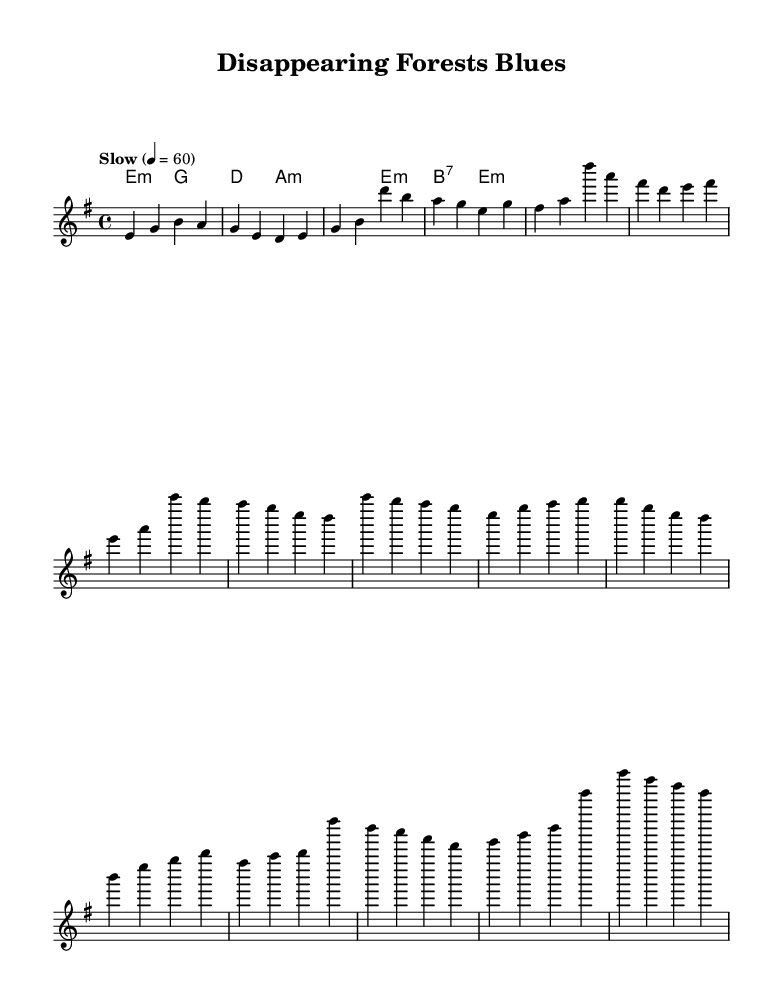What is the key signature of this music? The key signature is E minor, which has one sharp (F sharp). You can determine the key signature by looking at the key indicated at the beginning of the piece.
Answer: E minor What is the time signature of this music? The time signature shown is 4/4, meaning there are four beats in each measure and the quarter note receives one beat. This can be found in the upper left-hand corner of the music sheet.
Answer: 4/4 What is the tempo marking? The tempo marking indicates "Slow" at a quarter note equals 60 beats per minute. This is indicated next to the tempo text at the beginning of the score.
Answer: Slow How many measures does the verse contain? The verse consists of 8 measures, as counted from the beginning of the melody section down to where the chorus starts. Each measure is separated by vertical lines.
Answer: 8 Which chord is played in the first measure? The first measure features the E minor chord, which is indicated in the chord changes below the melody. The chord symbol for E minor is present in the harmonies below the melody staff.
Answer: E minor What structure does the song follow? The song follows a verse-chorus structure, with a distinct set of phrases for each part. You can identify these sections by the different rhythms and notes in the melody line and the harmonic progression.
Answer: Verse-chorus What emotion does this blues piece convey based on its theme? The blues piece reflects a sense of loss and sorrow due to the theme of disappearing forests, suggesting a melancholic emotion typical of blues music. This can be inferred from the title and the nature of the lyrics one would typically expect in a blues piece about environmental loss.
Answer: Melancholic 